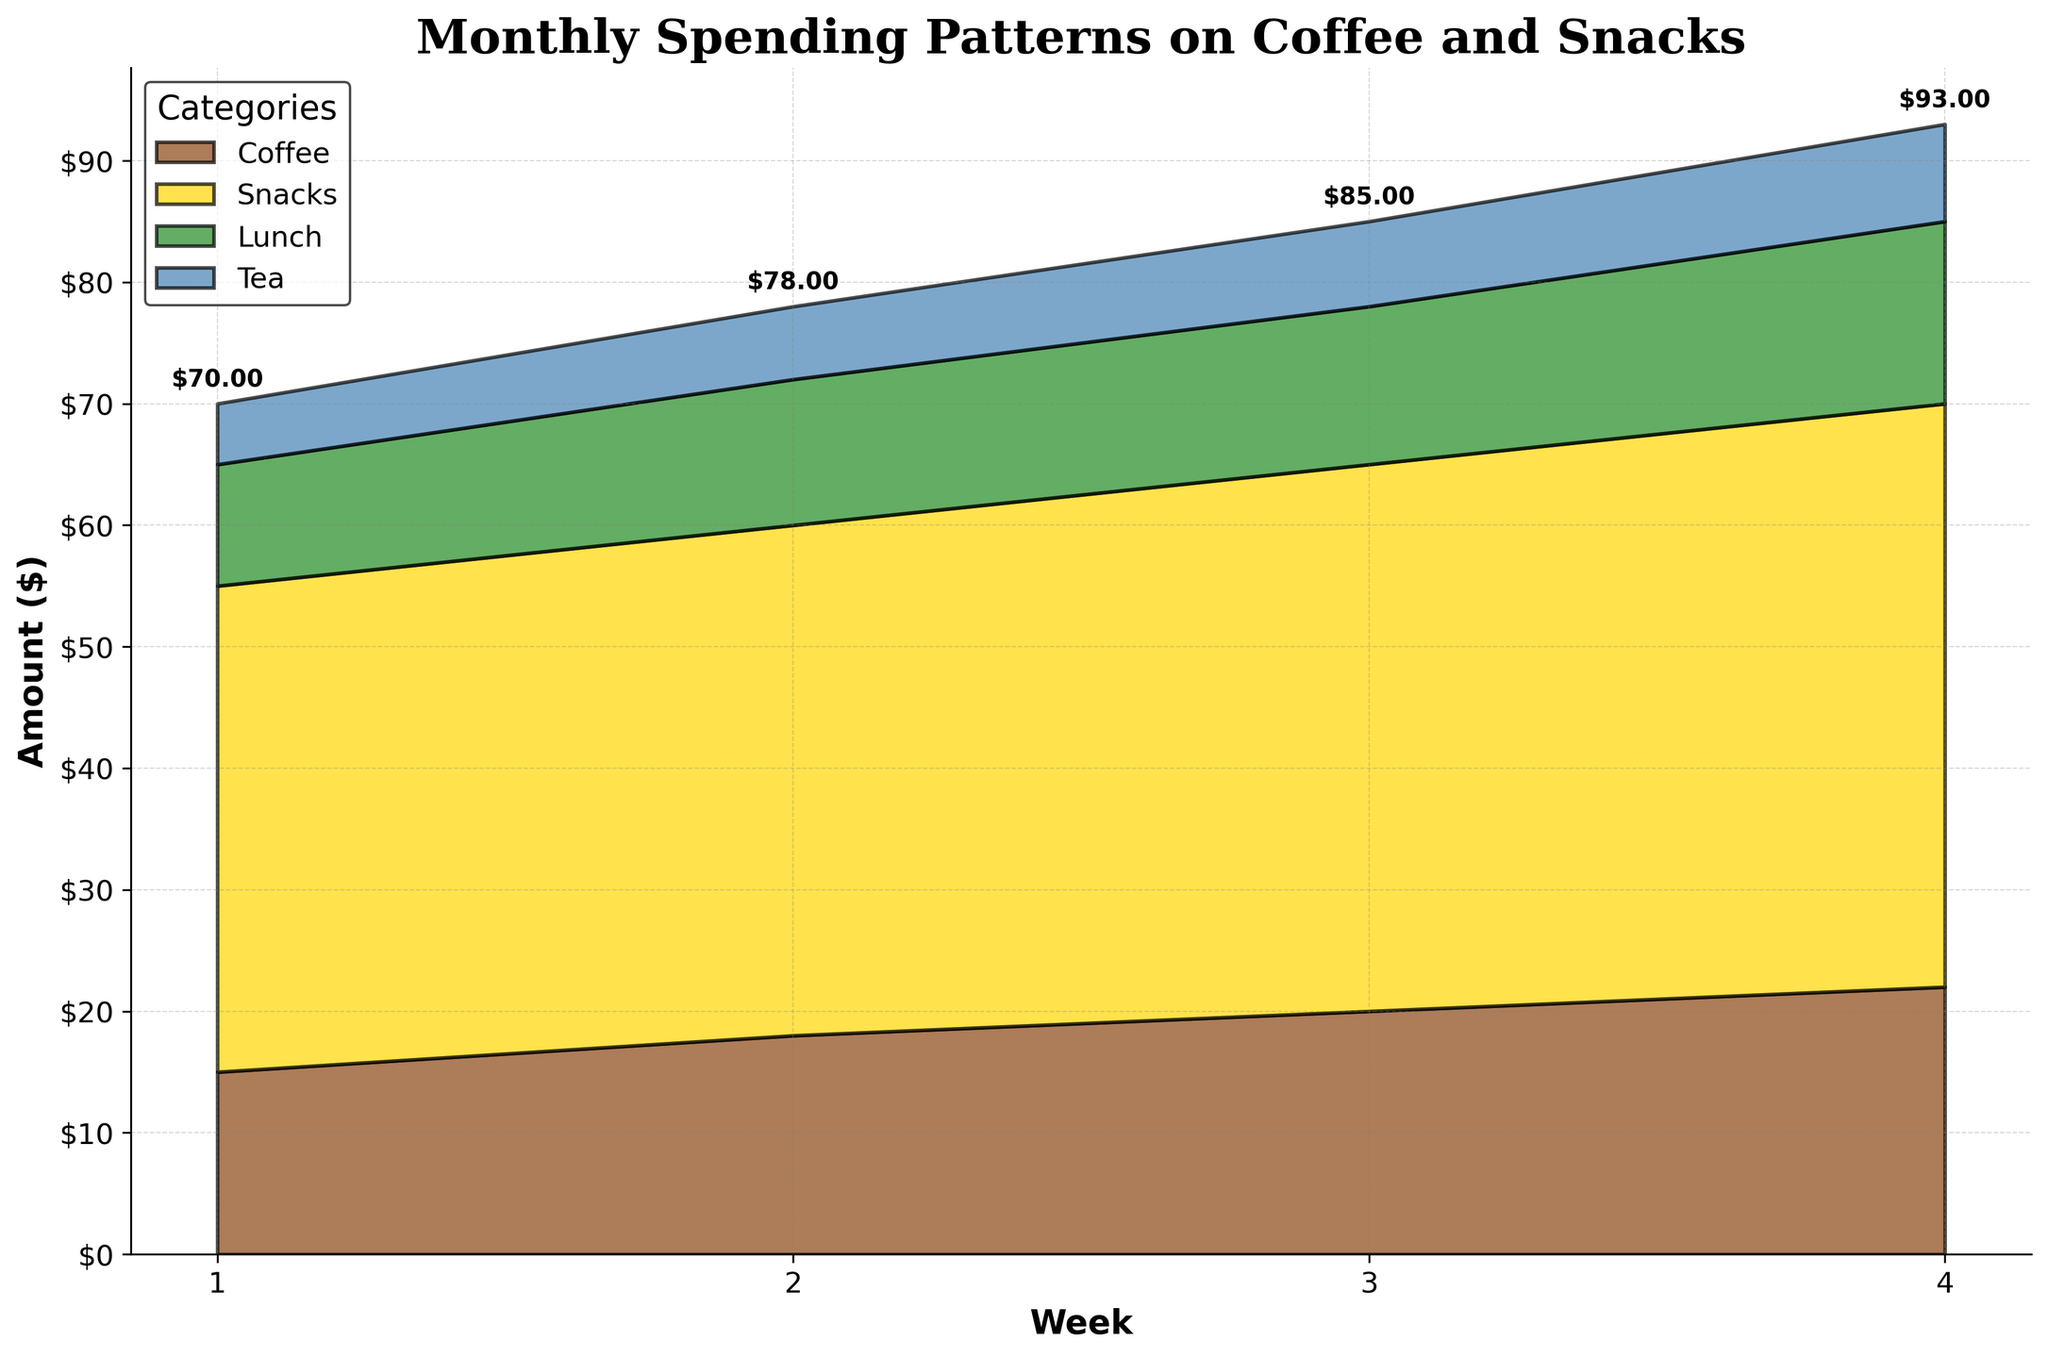How much did the office workers spend on coffee in Week 3? Locate the 'Coffee' category and the Week 3 data point on the chart, the amount is written near the point.
Answer: $20 Which category showed the highest spending in Week 4? Observe the topmost area in the Week 4 section of the chart, corresponding to the 'Lunch' category.
Answer: Lunch What is the total amount spent across all categories in Week 2? Sum the amounts for all categories in Week 2, which are: Coffee $18, Snacks $12, Lunch $42, and Tea $6. Total is $18 + $12 + $42 + $6 = $78.
Answer: $78 How does the spending on Tea compare between Week 1 and Week 4? Note the amounts for Tea in Week 1 and Week 4 from the chart and compare: Tea in Week 1 is $5, and in Week 4 it is $8. The Week 4 amount is $3 higher.
Answer: Increase by $3 What trend can be observed in the spending on Snacks across the four weeks? Examine the area corresponding to Snacks across the weeks: Week 1 ($10), Week 2 ($12), Week 3 ($13), Week 4 ($15). The amount increases consistently.
Answer: Increasing trend What is the combined spending on Coffee and Snacks in Week 1? Add the amounts for Coffee and Snacks in Week 1: Coffee ($15), Snacks ($10). Combined amount is $15 + $10 = $25.
Answer: $25 By how much did the spending on Lunch increase from Week 1 to Week 3? Find the amount for Lunch in Week 1 and Week 3 and calculate the difference: Week 1 ($40), Week 3 ($45). The increase is $45 - $40 = $5.
Answer: $5 Which category had the smallest spending in Week 2? Identify the lowest area in Week 2, which corresponds to the 'Tea' category.
Answer: Tea What is the average weekly spending on Lunch over the four weeks? Add the amounts for Lunch over the four weeks: ($40, $42, $45, $48). Average is calculated as (40 + 42 + 45 + 48) / 4 = 175 / 4 = $43.75.
Answer: $43.75 Which week's total spending annotation showed the highest value? Check the total spending annotations for all weeks: Week 1 ($70), Week 2 ($78), Week 3 ($85), Week 4 ($93). Week 4 has the highest value of $93.
Answer: Week 4 